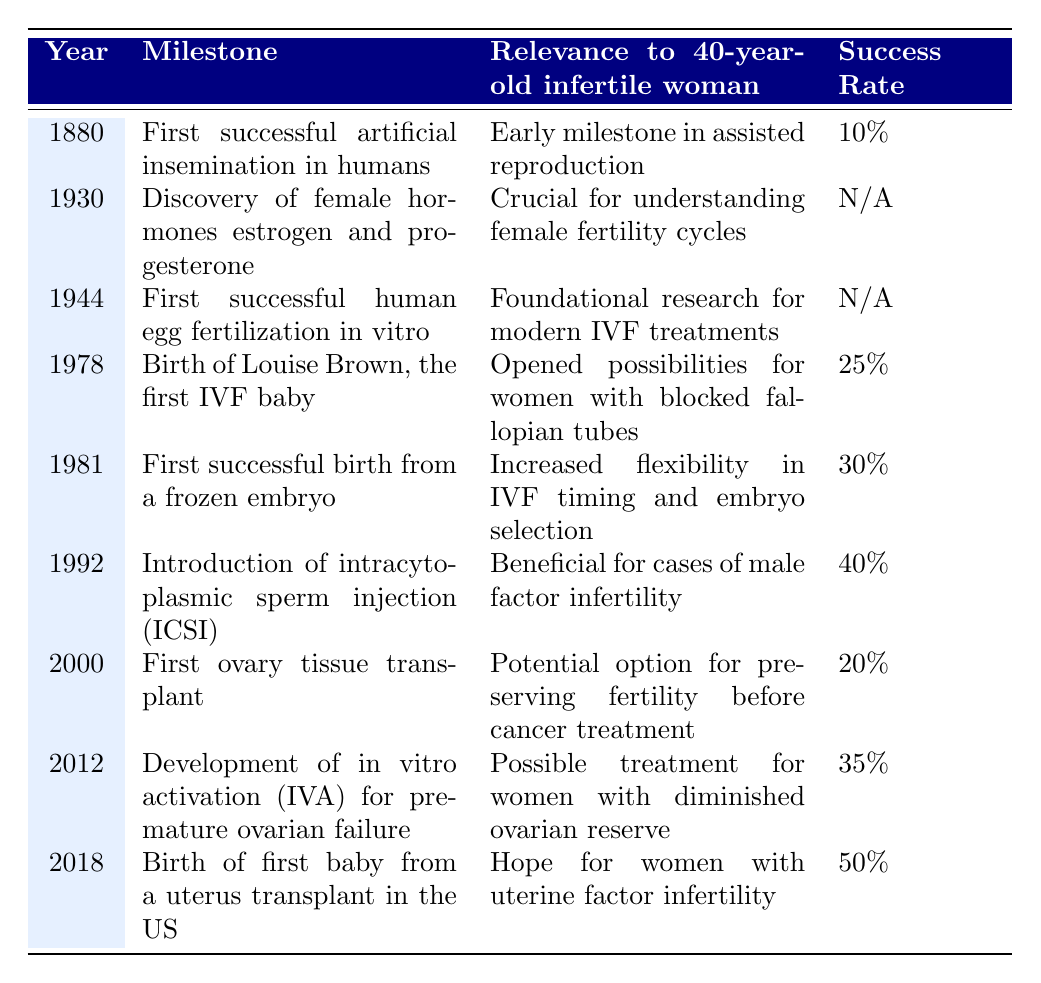What year did the first successful artificial insemination in humans occur? The table shows that the milestone "First successful artificial insemination in humans" occurred in the year 1880.
Answer: 1880 What milestone occurred in 2018? According to the table, the milestone in 2018 is "Birth of first baby from a uterus transplant in the US."
Answer: Birth of first baby from a uterus transplant in the US What is the success rate for the introduction of ICSI? The table lists the success rate for "Introduction of intracytoplasmic sperm injection (ICSI)" as 40%.
Answer: 40% True or False: The success rate for the first human egg fertilization in vitro is known. The table indicates that the success rate for "First successful human egg fertilization in vitro" is marked as N/A, meaning it is not available.
Answer: False What milestone had the highest success rate? By examining the success rates listed in the table, "Birth of first baby from a uterus transplant in the US" has the highest success rate of 50%.
Answer: Birth of first baby from a uterus transplant in the US What is the difference in success rates between the birth of Louise Brown and the first successful birth from a frozen embryo? The success rate for "Birth of Louise Brown" is 25%, and for "First successful birth from a frozen embryo" is 30%. The difference is 30% - 25% = 5%.
Answer: 5% List three milestones that have a success rate of 30% or higher. The milestones with a success rate of 30% or higher are: "First successful birth from a frozen embryo" (30%), "Introduction of intracytoplasmic sperm injection (ICSI)" (40%), and "Birth of first baby from a uterus transplant in the US" (50%).
Answer: First successful birth from a frozen embryo; Introduction of ICSI; Birth of first baby from uterus transplant How many milestones are listed with a success rate provided? There are 6 milestones listed with a success rate, as there are 3 milestones marked with N/A in the success rates column.
Answer: 6 Which milestone has the least relevance to a 40-year-old infertile woman? The milestone "Discovery of female hormones estrogen and progesterone" is described as crucial for understanding female fertility cycles, which may not directly relate to infertility issues compared to the others listed.
Answer: Discovery of female hormones estrogen and progesterone What is the average success rate for the milestones that have a known success rate? Summing the known success rates: 10%, 25%, 30%, 40%, 20%, 35%, and 50%, gives a total of 210%. There are 6 known rates, so the average is 210% / 6 = 35%.
Answer: 35% 